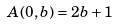<formula> <loc_0><loc_0><loc_500><loc_500>A ( 0 , b ) = 2 b + 1</formula> 